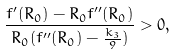<formula> <loc_0><loc_0><loc_500><loc_500>\frac { f ^ { \prime } ( R _ { 0 } ) - R _ { 0 } f ^ { \prime \prime } ( R _ { 0 } ) } { R _ { 0 } ( f ^ { \prime \prime } ( R _ { 0 } ) - \frac { k _ { 3 } } { 9 } ) } > 0 ,</formula> 